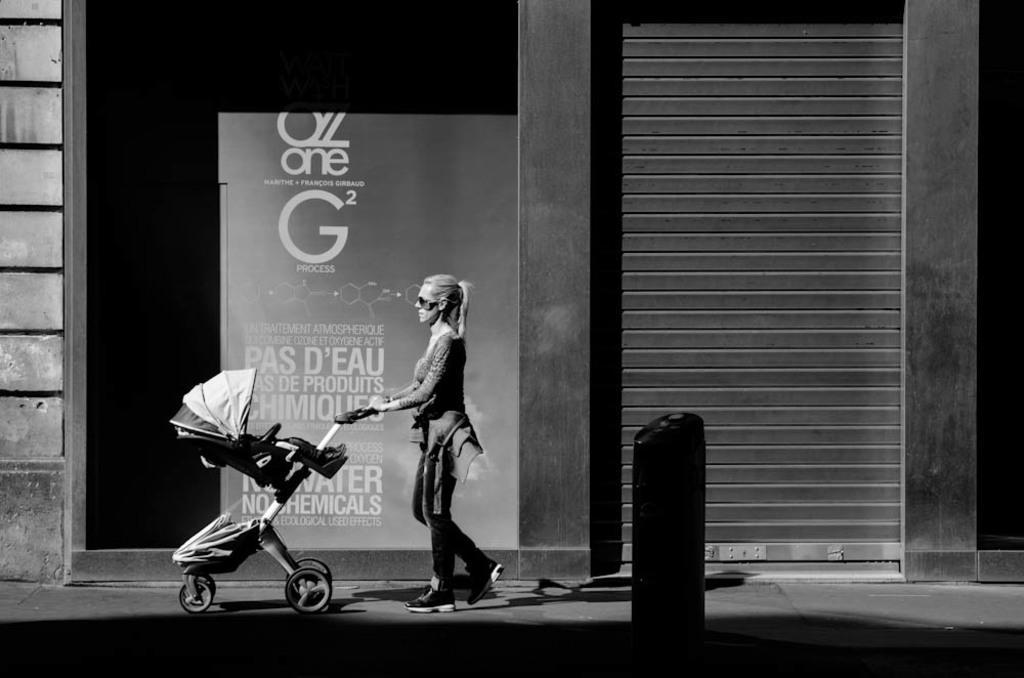How would you summarize this image in a sentence or two? In this image I can see a person walking and the person is holding a trolley. Background I can see a building and the image is in black and white. 